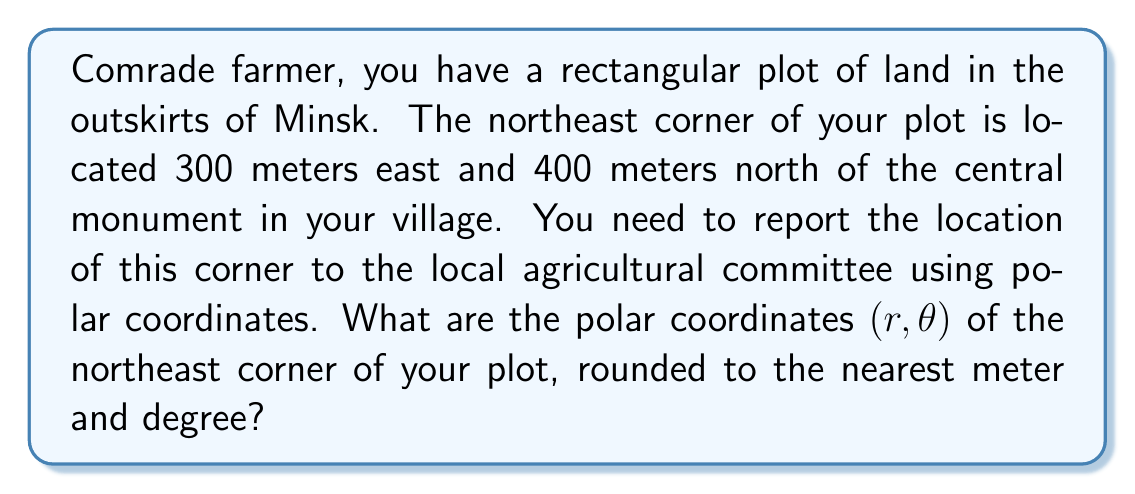Provide a solution to this math problem. To convert from rectangular coordinates $(x, y)$ to polar coordinates $(r, \theta)$, we use the following formulas:

$$r = \sqrt{x^2 + y^2}$$
$$\theta = \tan^{-1}\left(\frac{y}{x}\right)$$

Given:
- $x = 300$ meters (east)
- $y = 400$ meters (north)

Step 1: Calculate $r$
$$r = \sqrt{300^2 + 400^2} = \sqrt{90,000 + 160,000} = \sqrt{250,000} \approx 500$$

Step 2: Calculate $\theta$
$$\theta = \tan^{-1}\left(\frac{400}{300}\right) \approx 53.13^\circ$$

Step 3: Adjust $\theta$ if necessary
Since both $x$ and $y$ are positive, the angle is in the first quadrant, so no adjustment is needed.

Step 4: Round the results
$r \approx 500$ meters (rounded to the nearest meter)
$\theta \approx 53^\circ$ (rounded to the nearest degree)

[asy]
import geometry;

size(200);
dot((0,0),Fill(black));
draw((0,0)--(6,8),Arrow);
draw((0,0)--(6,0),dashed);
draw((6,0)--(6,8),dashed);
draw(arc((0,0),1,0,53),Arrow);

label("300 m", (3,-0.5));
label("400 m", (6.5,4));
label("500 m", (3,4), NE);
label("53°", (1,0.5));
label("(0,0)", (-0.5,-0.5));
label("(300,400)", (6,8), NE);
[/asy]
Answer: The polar coordinates of the northeast corner of the plot are approximately $(500 \text{ m}, 53^\circ)$. 